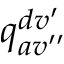Convert formula to latex. <formula><loc_0><loc_0><loc_500><loc_500>q _ { a v ^ { \prime \prime } } ^ { d v ^ { \prime } }</formula> 